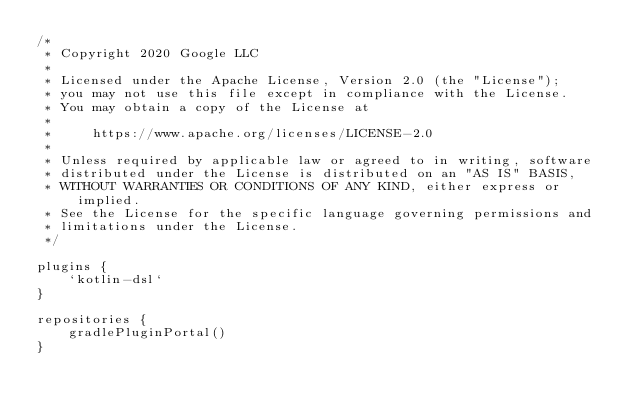<code> <loc_0><loc_0><loc_500><loc_500><_Kotlin_>/*
 * Copyright 2020 Google LLC
 *
 * Licensed under the Apache License, Version 2.0 (the "License");
 * you may not use this file except in compliance with the License.
 * You may obtain a copy of the License at
 *
 *     https://www.apache.org/licenses/LICENSE-2.0
 *
 * Unless required by applicable law or agreed to in writing, software
 * distributed under the License is distributed on an "AS IS" BASIS,
 * WITHOUT WARRANTIES OR CONDITIONS OF ANY KIND, either express or implied.
 * See the License for the specific language governing permissions and
 * limitations under the License.
 */

plugins {
    `kotlin-dsl`
}

repositories {
    gradlePluginPortal()
}</code> 